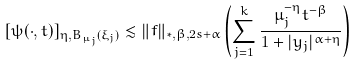<formula> <loc_0><loc_0><loc_500><loc_500>[ \psi ( \cdot , t ) ] _ { \eta , B _ { \mu _ { j } } ( \xi _ { j } ) } \lesssim \| f \| _ { * , \beta , 2 s + \alpha } \left ( \sum _ { j = 1 } ^ { k } \frac { \mu _ { j } ^ { - \eta } t ^ { - \beta } } { 1 + | y _ { j } | ^ { \alpha + \eta } } \right )</formula> 